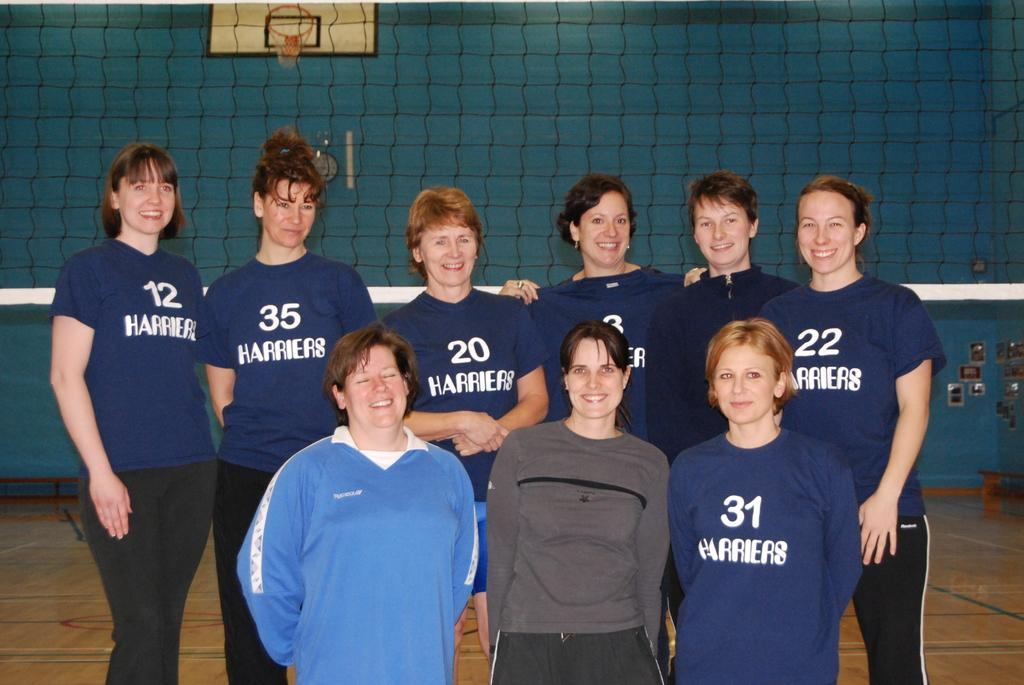<image>
Summarize the visual content of the image. A Harriers volleyball team poses for a picture in front of a net. 